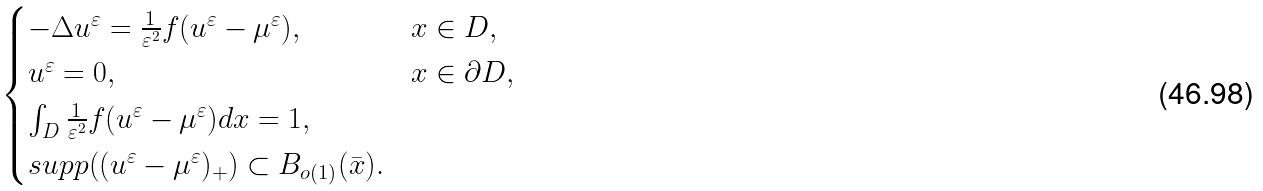Convert formula to latex. <formula><loc_0><loc_0><loc_500><loc_500>\begin{cases} - \Delta u ^ { \varepsilon } = \frac { 1 } { \varepsilon ^ { 2 } } f ( u ^ { \varepsilon } - \mu ^ { \varepsilon } ) , & x \in D , \\ u ^ { \varepsilon } = 0 , & x \in \partial D , \\ \int _ { D } \frac { 1 } { \varepsilon ^ { 2 } } f ( u ^ { \varepsilon } - \mu ^ { \varepsilon } ) d x = 1 , \\ s u p p ( ( u ^ { \varepsilon } - \mu ^ { \varepsilon } ) _ { + } ) \subset B _ { o ( 1 ) } ( \bar { x } ) . \end{cases}</formula> 